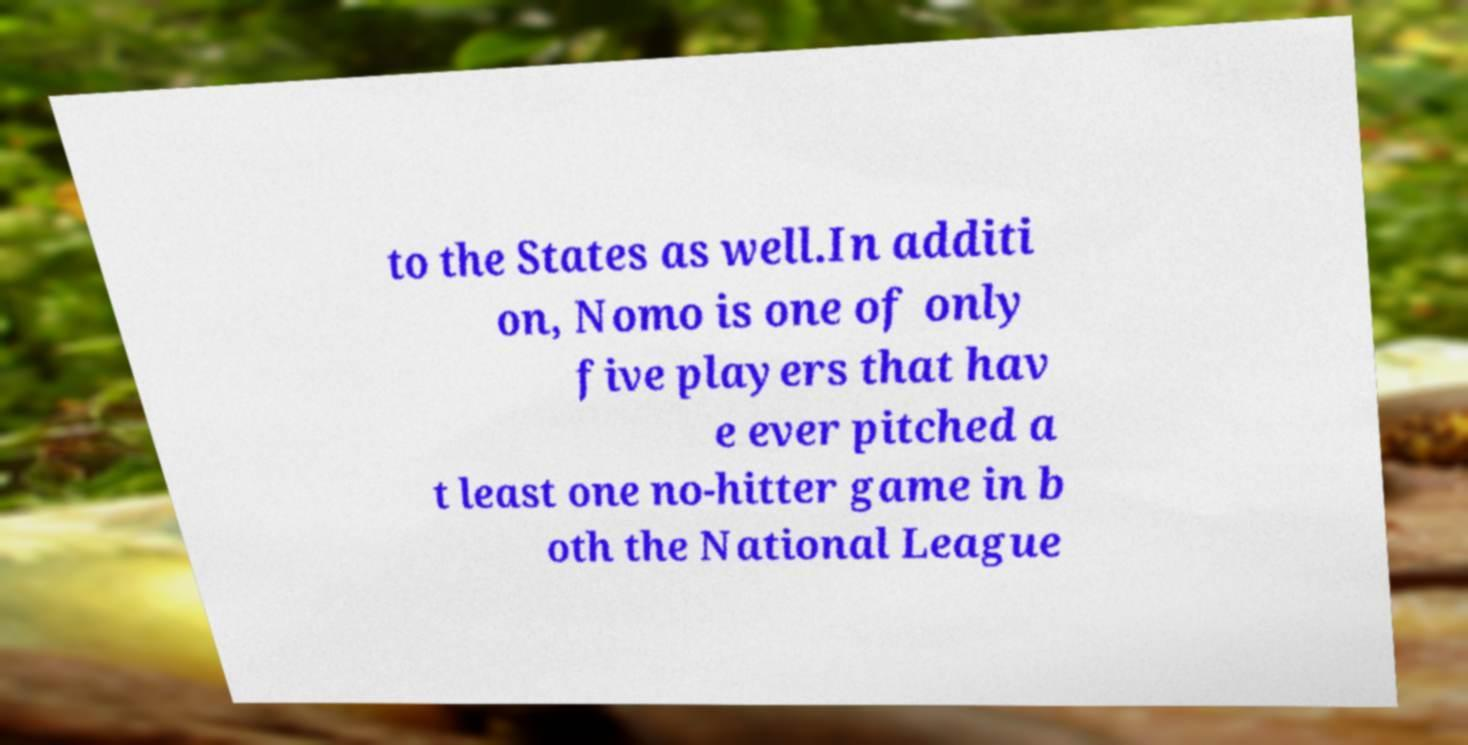I need the written content from this picture converted into text. Can you do that? to the States as well.In additi on, Nomo is one of only five players that hav e ever pitched a t least one no-hitter game in b oth the National League 